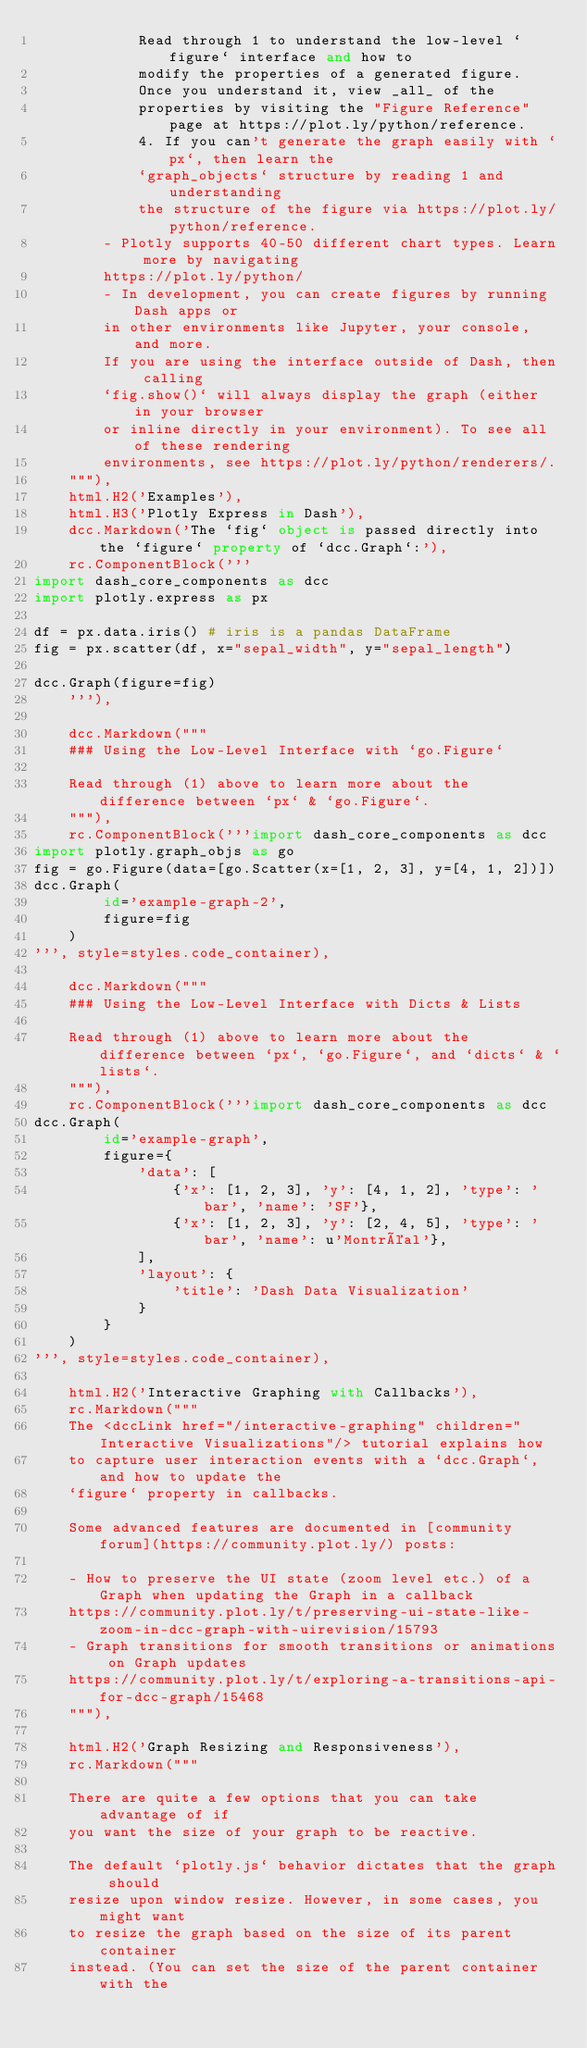<code> <loc_0><loc_0><loc_500><loc_500><_Python_>            Read through 1 to understand the low-level `figure` interface and how to
            modify the properties of a generated figure.
            Once you understand it, view _all_ of the
            properties by visiting the "Figure Reference" page at https://plot.ly/python/reference.
            4. If you can't generate the graph easily with `px`, then learn the
            `graph_objects` structure by reading 1 and understanding
            the structure of the figure via https://plot.ly/python/reference.
        - Plotly supports 40-50 different chart types. Learn more by navigating
        https://plot.ly/python/
        - In development, you can create figures by running Dash apps or
        in other environments like Jupyter, your console, and more.
        If you are using the interface outside of Dash, then calling
        `fig.show()` will always display the graph (either in your browser
        or inline directly in your environment). To see all of these rendering
        environments, see https://plot.ly/python/renderers/.
    """),
    html.H2('Examples'),
    html.H3('Plotly Express in Dash'),
    dcc.Markdown('The `fig` object is passed directly into the `figure` property of `dcc.Graph`:'),
    rc.ComponentBlock('''
import dash_core_components as dcc
import plotly.express as px

df = px.data.iris() # iris is a pandas DataFrame
fig = px.scatter(df, x="sepal_width", y="sepal_length")

dcc.Graph(figure=fig)
    '''),

    dcc.Markdown("""
    ### Using the Low-Level Interface with `go.Figure`

    Read through (1) above to learn more about the difference between `px` & `go.Figure`.
    """),
    rc.ComponentBlock('''import dash_core_components as dcc
import plotly.graph_objs as go
fig = go.Figure(data=[go.Scatter(x=[1, 2, 3], y=[4, 1, 2])])
dcc.Graph(
        id='example-graph-2',
        figure=fig
    )
''', style=styles.code_container),

    dcc.Markdown("""
    ### Using the Low-Level Interface with Dicts & Lists

    Read through (1) above to learn more about the difference between `px`, `go.Figure`, and `dicts` & `lists`.
    """),
    rc.ComponentBlock('''import dash_core_components as dcc
dcc.Graph(
        id='example-graph',
        figure={
            'data': [
                {'x': [1, 2, 3], 'y': [4, 1, 2], 'type': 'bar', 'name': 'SF'},
                {'x': [1, 2, 3], 'y': [2, 4, 5], 'type': 'bar', 'name': u'Montréal'},
            ],
            'layout': {
                'title': 'Dash Data Visualization'
            }
        }
    )
''', style=styles.code_container),

    html.H2('Interactive Graphing with Callbacks'),
    rc.Markdown("""
    The <dccLink href="/interactive-graphing" children="Interactive Visualizations"/> tutorial explains how
    to capture user interaction events with a `dcc.Graph`, and how to update the
    `figure` property in callbacks.

    Some advanced features are documented in [community forum](https://community.plot.ly/) posts:

    - How to preserve the UI state (zoom level etc.) of a Graph when updating the Graph in a callback
    https://community.plot.ly/t/preserving-ui-state-like-zoom-in-dcc-graph-with-uirevision/15793
    - Graph transitions for smooth transitions or animations on Graph updates
    https://community.plot.ly/t/exploring-a-transitions-api-for-dcc-graph/15468
    """),

    html.H2('Graph Resizing and Responsiveness'),
    rc.Markdown("""

    There are quite a few options that you can take advantage of if
    you want the size of your graph to be reactive.

    The default `plotly.js` behavior dictates that the graph should
    resize upon window resize. However, in some cases, you might want
    to resize the graph based on the size of its parent container
    instead. (You can set the size of the parent container with the</code> 